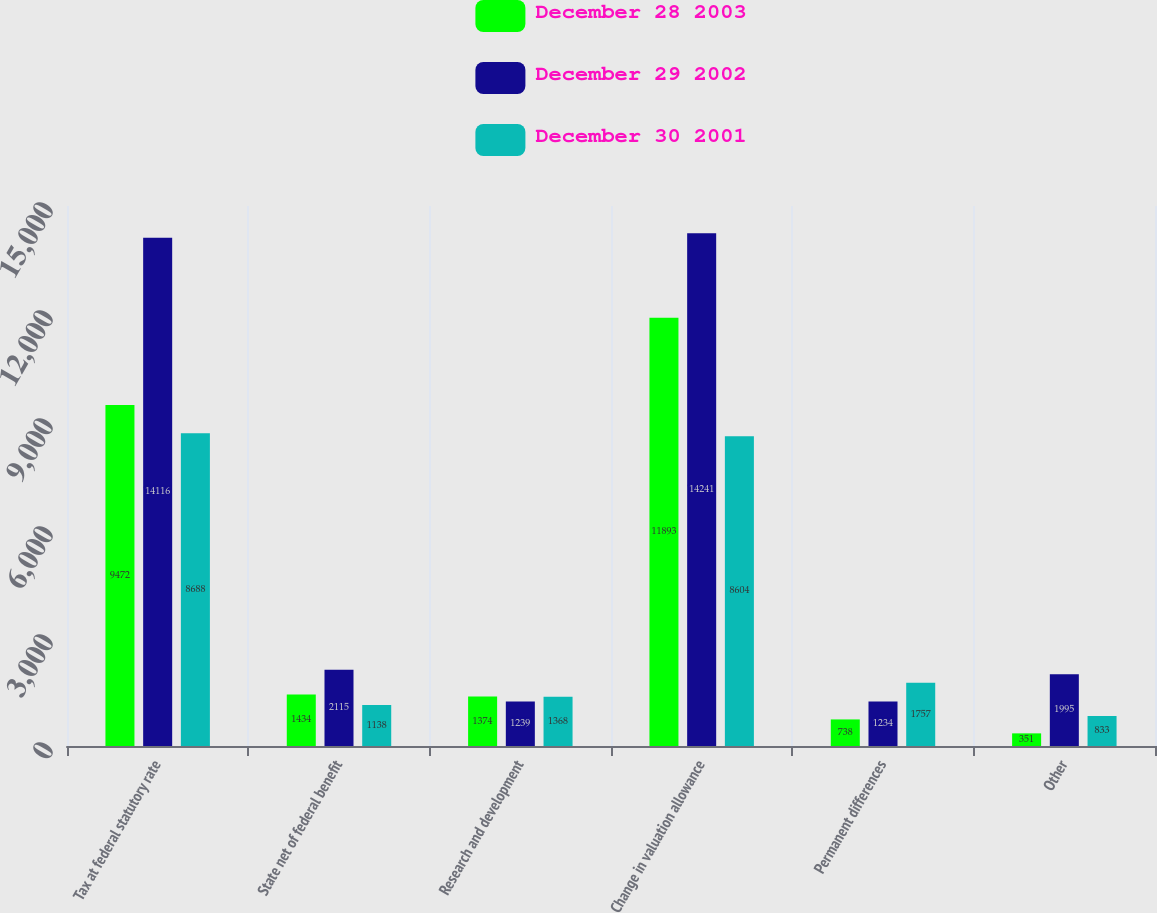Convert chart. <chart><loc_0><loc_0><loc_500><loc_500><stacked_bar_chart><ecel><fcel>Tax at federal statutory rate<fcel>State net of federal benefit<fcel>Research and development<fcel>Change in valuation allowance<fcel>Permanent differences<fcel>Other<nl><fcel>December 28 2003<fcel>9472<fcel>1434<fcel>1374<fcel>11893<fcel>738<fcel>351<nl><fcel>December 29 2002<fcel>14116<fcel>2115<fcel>1239<fcel>14241<fcel>1234<fcel>1995<nl><fcel>December 30 2001<fcel>8688<fcel>1138<fcel>1368<fcel>8604<fcel>1757<fcel>833<nl></chart> 